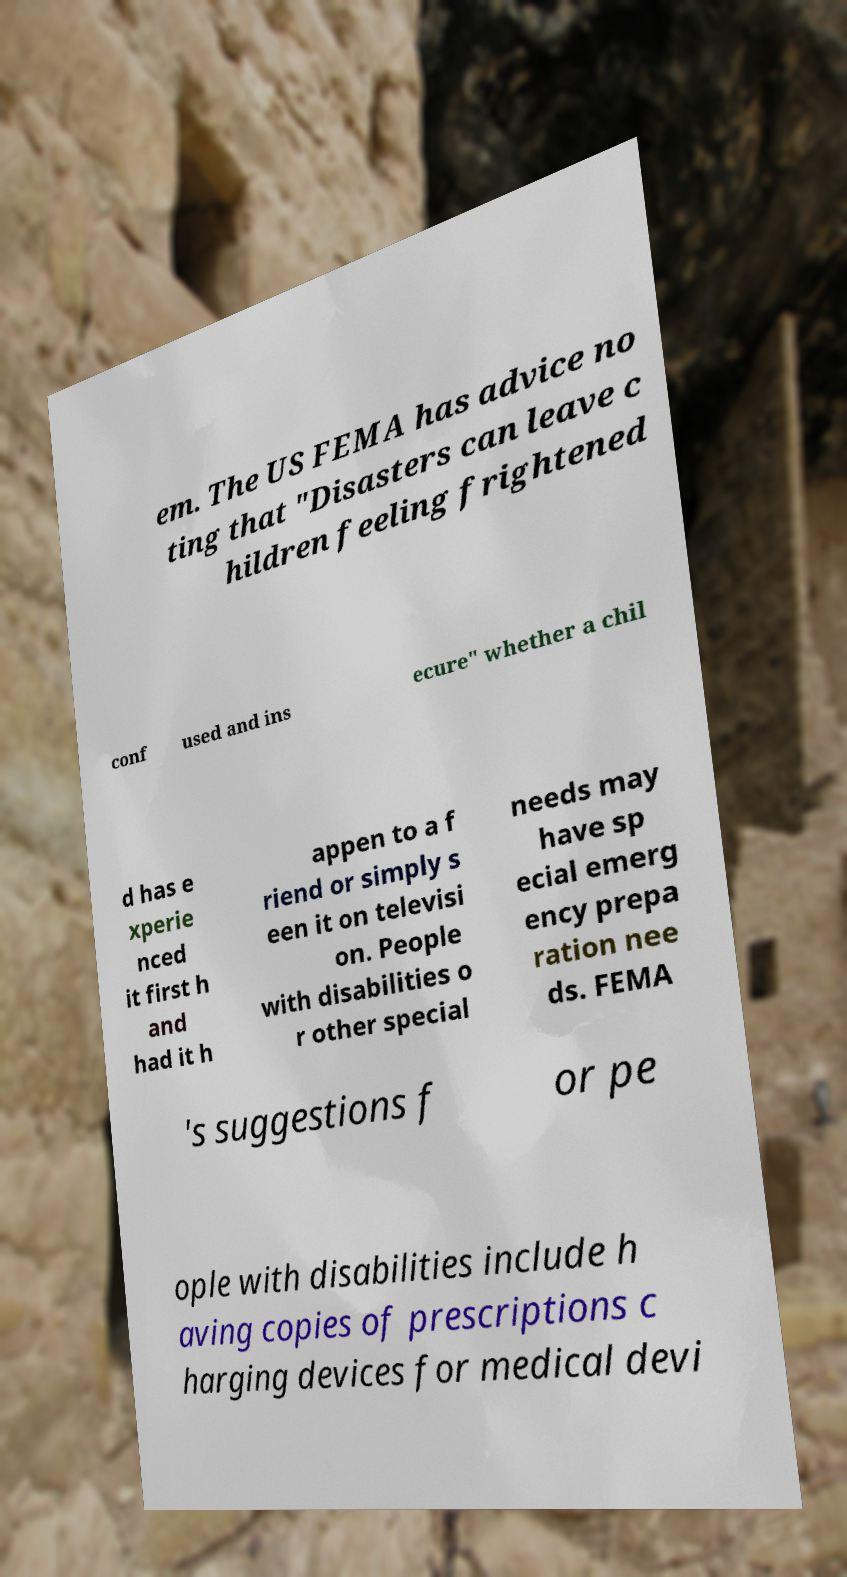What messages or text are displayed in this image? I need them in a readable, typed format. em. The US FEMA has advice no ting that "Disasters can leave c hildren feeling frightened conf used and ins ecure" whether a chil d has e xperie nced it first h and had it h appen to a f riend or simply s een it on televisi on. People with disabilities o r other special needs may have sp ecial emerg ency prepa ration nee ds. FEMA 's suggestions f or pe ople with disabilities include h aving copies of prescriptions c harging devices for medical devi 